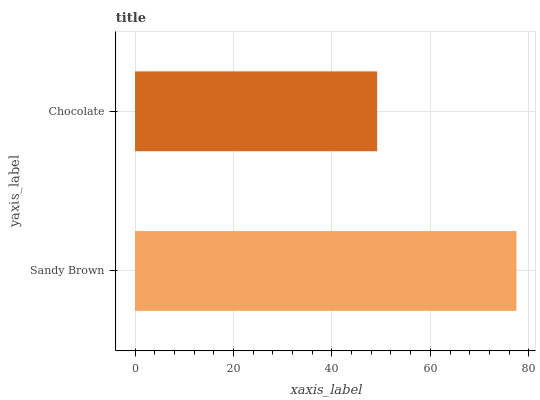Is Chocolate the minimum?
Answer yes or no. Yes. Is Sandy Brown the maximum?
Answer yes or no. Yes. Is Chocolate the maximum?
Answer yes or no. No. Is Sandy Brown greater than Chocolate?
Answer yes or no. Yes. Is Chocolate less than Sandy Brown?
Answer yes or no. Yes. Is Chocolate greater than Sandy Brown?
Answer yes or no. No. Is Sandy Brown less than Chocolate?
Answer yes or no. No. Is Sandy Brown the high median?
Answer yes or no. Yes. Is Chocolate the low median?
Answer yes or no. Yes. Is Chocolate the high median?
Answer yes or no. No. Is Sandy Brown the low median?
Answer yes or no. No. 